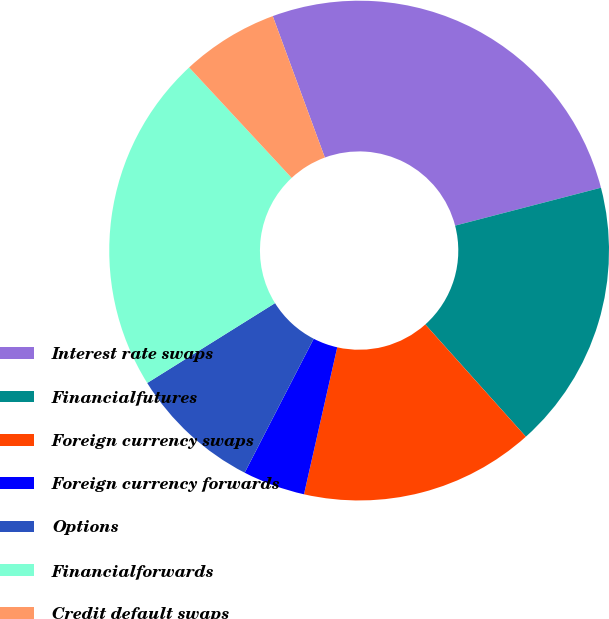<chart> <loc_0><loc_0><loc_500><loc_500><pie_chart><fcel>Interest rate swaps<fcel>Financialfutures<fcel>Foreign currency swaps<fcel>Foreign currency forwards<fcel>Options<fcel>Financialforwards<fcel>Credit default swaps<nl><fcel>26.57%<fcel>17.42%<fcel>15.17%<fcel>4.03%<fcel>8.54%<fcel>21.98%<fcel>6.29%<nl></chart> 